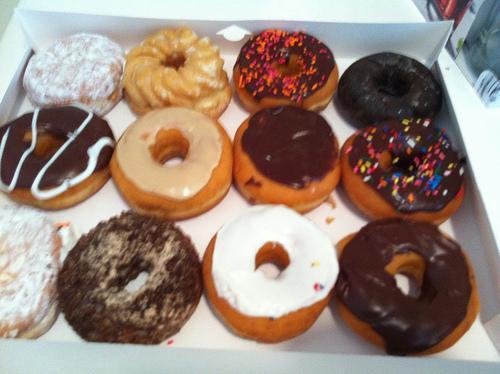How many doughnuts have sprinkles?
Give a very brief answer. 3. How many filled doughnuts are there?
Give a very brief answer. 2. 